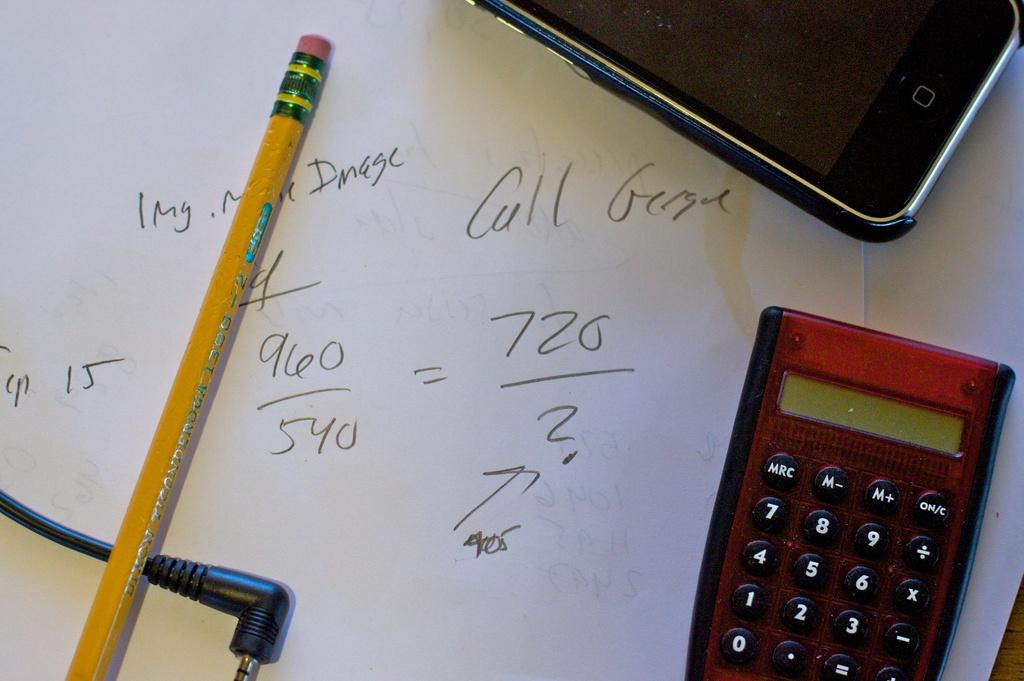Who should be called?
Offer a terse response. George. What number do you see?
Your response must be concise. 720. 